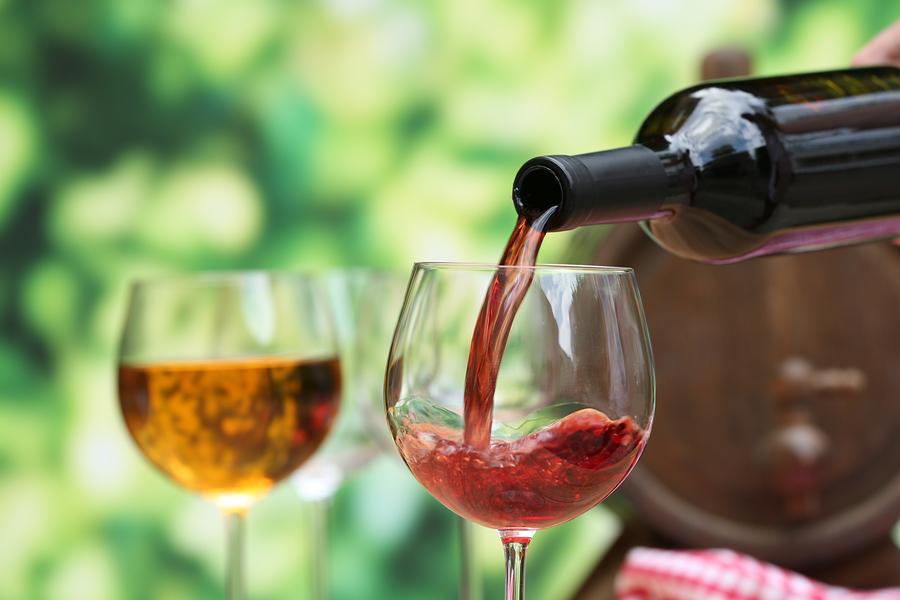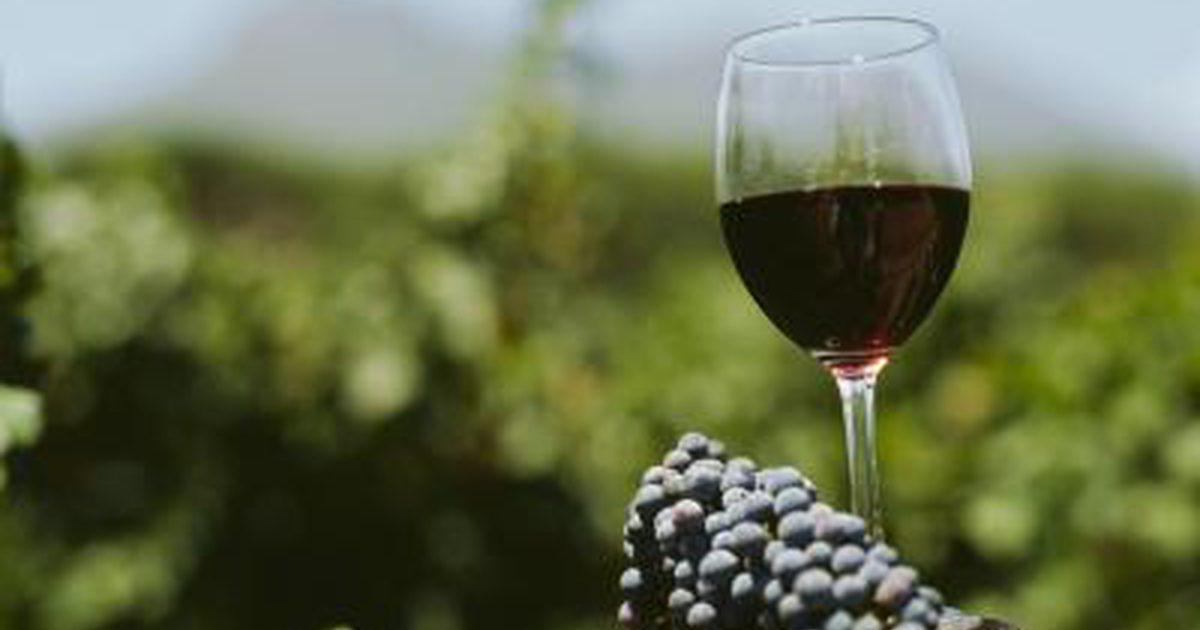The first image is the image on the left, the second image is the image on the right. Assess this claim about the two images: "There is a wine bottle in the iamge on the left". Correct or not? Answer yes or no. Yes. The first image is the image on the left, the second image is the image on the right. For the images shown, is this caption "Wine is being poured in at least one image." true? Answer yes or no. Yes. 